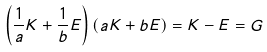<formula> <loc_0><loc_0><loc_500><loc_500>\left ( \frac { 1 } { a } K + \frac { 1 } { b } E \right ) \left ( a K + b E \right ) = K - E = G</formula> 